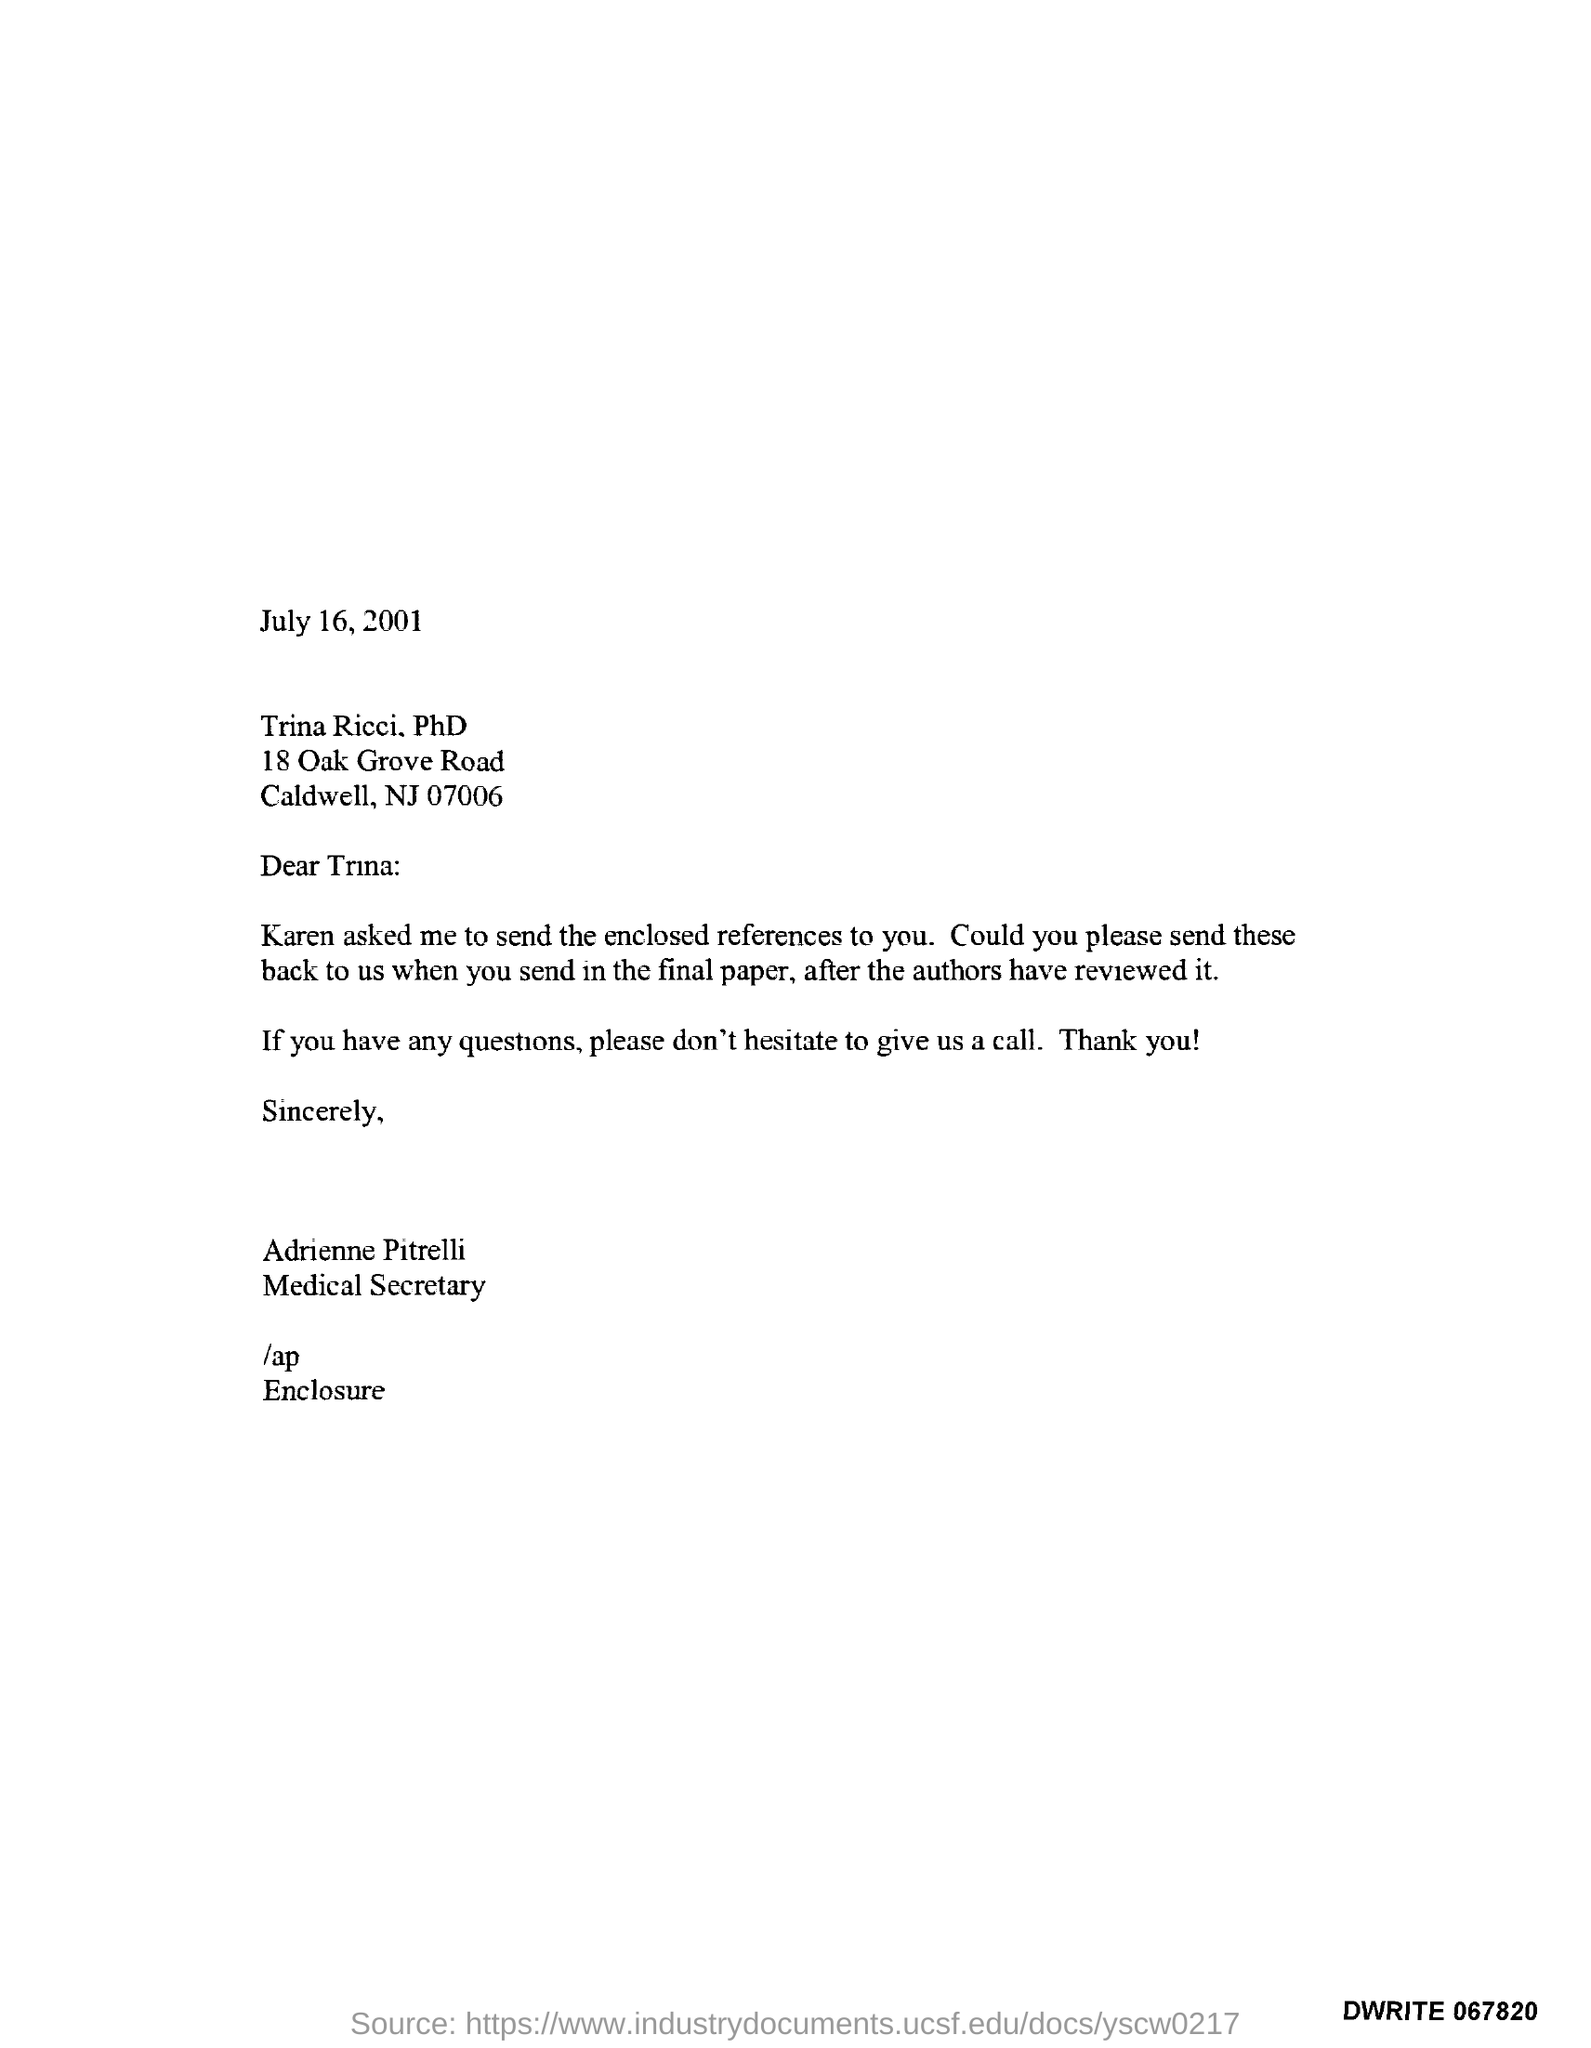Who is the Medical Secretary?
Your answer should be very brief. Adrienne Pitrelli. 